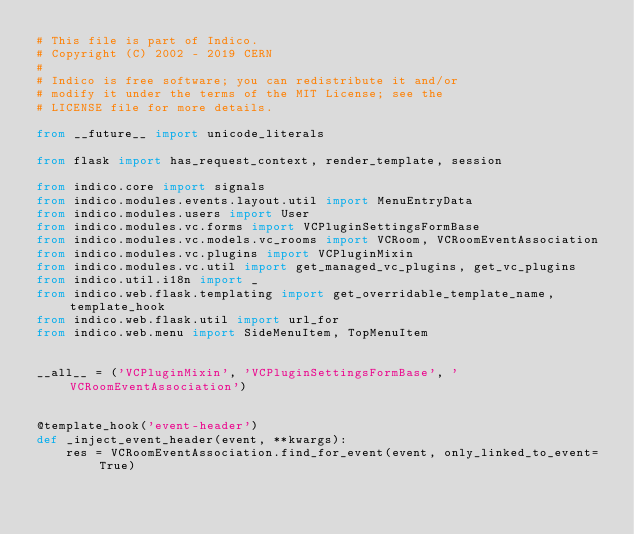Convert code to text. <code><loc_0><loc_0><loc_500><loc_500><_Python_># This file is part of Indico.
# Copyright (C) 2002 - 2019 CERN
#
# Indico is free software; you can redistribute it and/or
# modify it under the terms of the MIT License; see the
# LICENSE file for more details.

from __future__ import unicode_literals

from flask import has_request_context, render_template, session

from indico.core import signals
from indico.modules.events.layout.util import MenuEntryData
from indico.modules.users import User
from indico.modules.vc.forms import VCPluginSettingsFormBase
from indico.modules.vc.models.vc_rooms import VCRoom, VCRoomEventAssociation
from indico.modules.vc.plugins import VCPluginMixin
from indico.modules.vc.util import get_managed_vc_plugins, get_vc_plugins
from indico.util.i18n import _
from indico.web.flask.templating import get_overridable_template_name, template_hook
from indico.web.flask.util import url_for
from indico.web.menu import SideMenuItem, TopMenuItem


__all__ = ('VCPluginMixin', 'VCPluginSettingsFormBase', 'VCRoomEventAssociation')


@template_hook('event-header')
def _inject_event_header(event, **kwargs):
    res = VCRoomEventAssociation.find_for_event(event, only_linked_to_event=True)</code> 